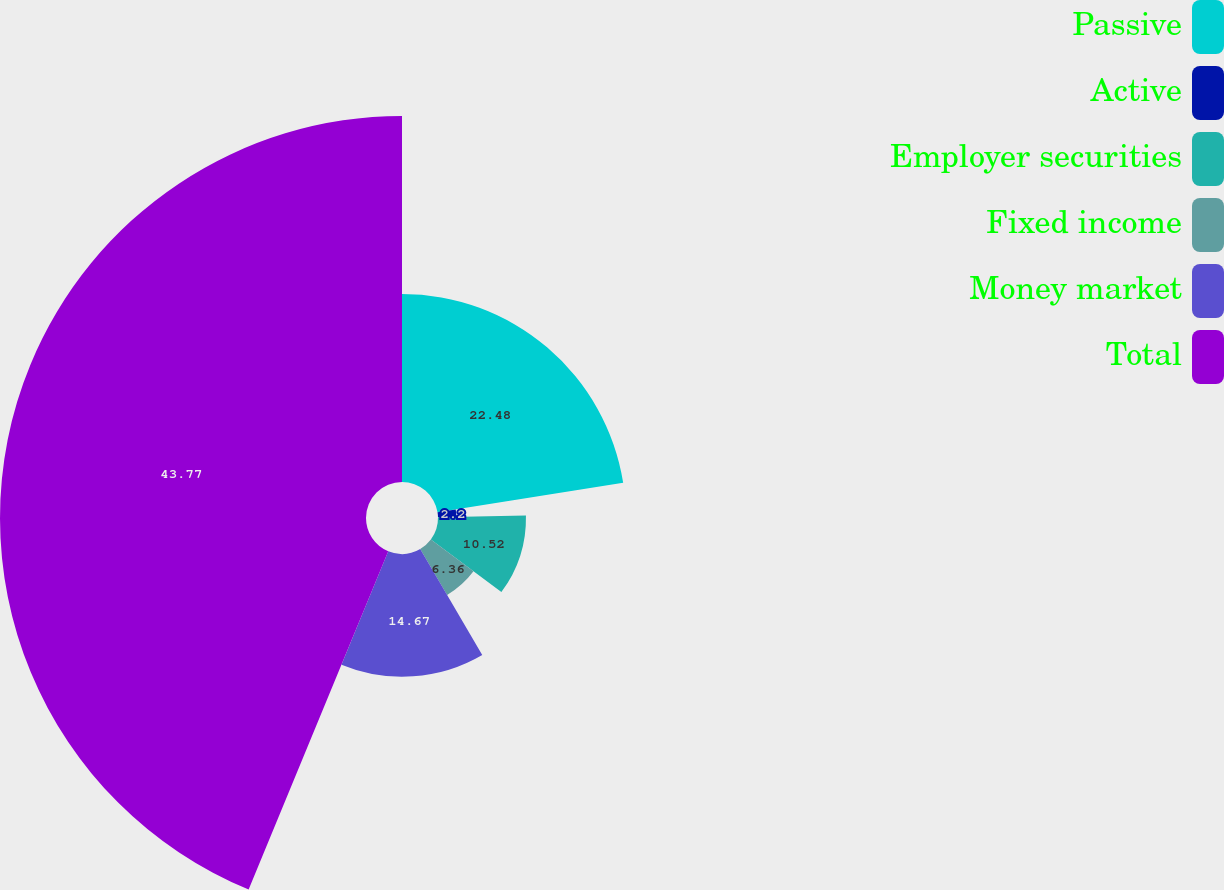Convert chart to OTSL. <chart><loc_0><loc_0><loc_500><loc_500><pie_chart><fcel>Passive<fcel>Active<fcel>Employer securities<fcel>Fixed income<fcel>Money market<fcel>Total<nl><fcel>22.48%<fcel>2.2%<fcel>10.52%<fcel>6.36%<fcel>14.67%<fcel>43.77%<nl></chart> 